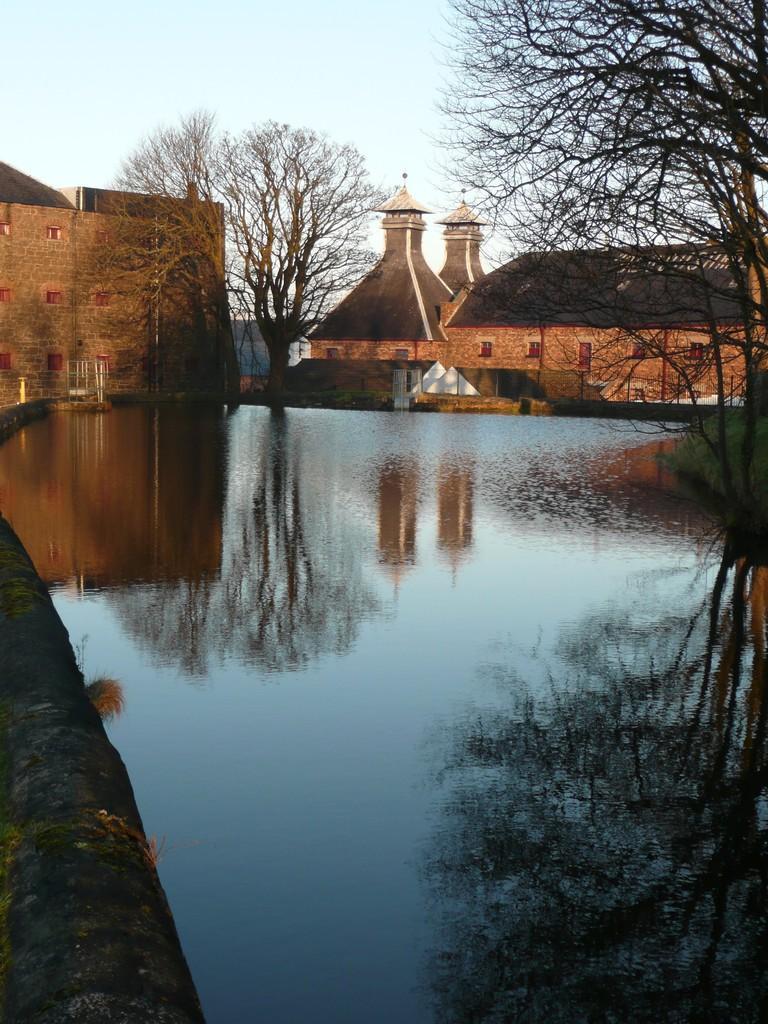Describe this image in one or two sentences. In this picture we can see many houses and trees alongside the river. 